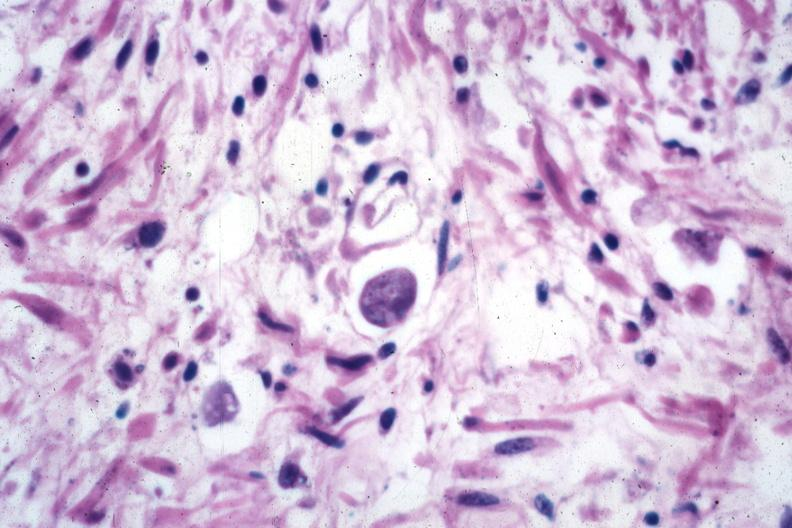s colon present?
Answer the question using a single word or phrase. Yes 